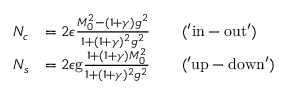<formula> <loc_0><loc_0><loc_500><loc_500>\begin{array} { r l } { N _ { c } } & { = 2 \epsilon \frac { M _ { 0 } ^ { 2 } - ( 1 + \gamma ) g ^ { 2 } } { 1 + ( 1 + \gamma ) ^ { 2 } g ^ { 2 } } \quad ( ^ { \prime } i n - o u t ^ { \prime } ) } \\ { N _ { s } } & { = 2 \epsilon g \frac { 1 + ( 1 + \gamma ) M _ { 0 } ^ { 2 } } { 1 + ( 1 + \gamma ) ^ { 2 } g ^ { 2 } } \quad ( ^ { \prime } u p - d o w n ^ { \prime } ) } \end{array}</formula> 